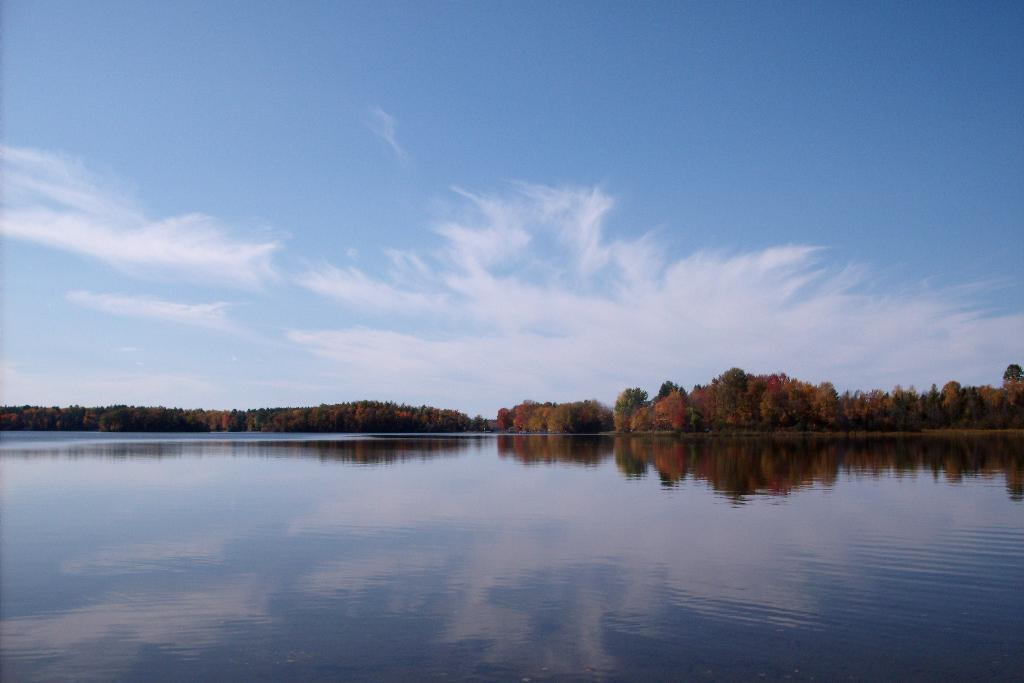What can be seen in the background of the image? The sky is visible in the image. What is the condition of the sky in the image? Clouds are present in the sky. What type of vegetation is visible in the image? There are trees in the image. What natural feature can be seen in the image? A river is present in the image. What type of art can be seen hanging on the trees in the image? There is no art present in the image; it features natural elements such as the sky, clouds, trees, and a river. 